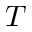<formula> <loc_0><loc_0><loc_500><loc_500>T</formula> 